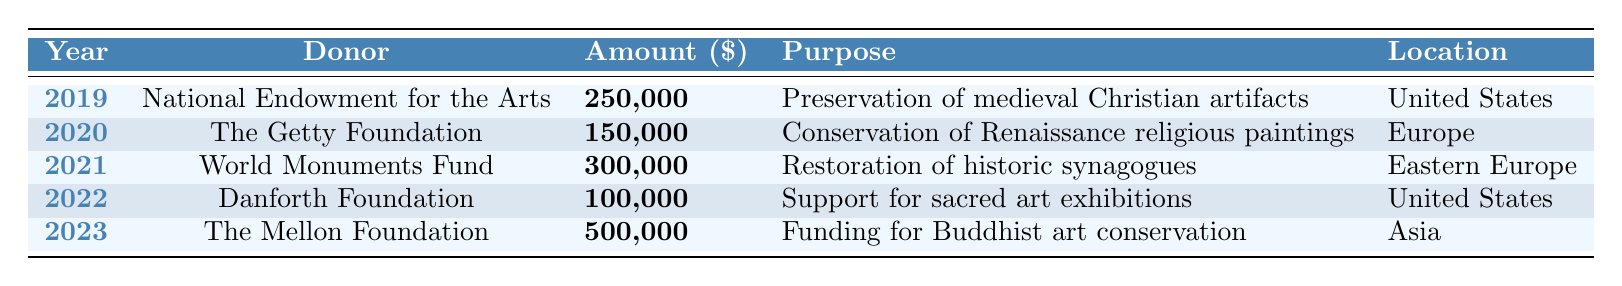What was the largest contribution to a religious art preservation fund in the last five years? The largest contribution listed in the table is from The Mellon Foundation in 2023, with an amount of 500,000.
Answer: 500,000 Which donor contributed to the preservation of medieval Christian artifacts? According to the table, the donor that contributed to this purpose is the National Endowment for the Arts in 2019 with a contribution of 250,000.
Answer: National Endowment for the Arts What is the total amount donated in 2020 and 2022 combined? The contributions in 2020 and 2022 are 150,000 and 100,000, respectively. Adding these two amounts gives 150,000 + 100,000 = 250,000.
Answer: 250,000 Did any donor contribute specifically to the restoration of historic synagogues? Yes, the World Monuments Fund contributed to the restoration of historic synagogues in 2021.
Answer: Yes Which location received the most funding for religious art preservation in 2023? The location with the most funding in 2023 is Asia, with a contribution from The Mellon Foundation of 500,000 for Buddhist art conservation.
Answer: Asia What is the average contribution amount over the five years? The total contributions over five years are 250,000 + 150,000 + 300,000 + 100,000 + 500,000 = 1,300,000. There are five contributions, so the average is 1,300,000 / 5 = 260,000.
Answer: 260,000 Was there a contribution made for conservation of Renaissance religious paintings? Yes, The Getty Foundation made a contribution for conservation of Renaissance religious paintings in 2020.
Answer: Yes Which donor had the lowest contribution amount among the entries? The Danforth Foundation had the lowest contribution of 100,000 in 2022.
Answer: Danforth Foundation What purposes did donors support in Eastern Europe according to the data? The table indicates that the World Monuments Fund supported the restoration of historic synagogues in Eastern Europe.
Answer: Restoration of historic synagogues List all donors that contributed to the United States for religious art preservation. The donors contributing to religious art preservation in the United States are the National Endowment for the Arts and Danforth Foundation.
Answer: National Endowment for the Arts, Danforth Foundation How much more did The Mellon Foundation contribute in 2023 compared to the Danforth Foundation in 2022? The Mellon Foundation contributed 500,000 in 2023, while the Danforth Foundation contributed 100,000 in 2022. The difference is 500,000 - 100,000 = 400,000.
Answer: 400,000 